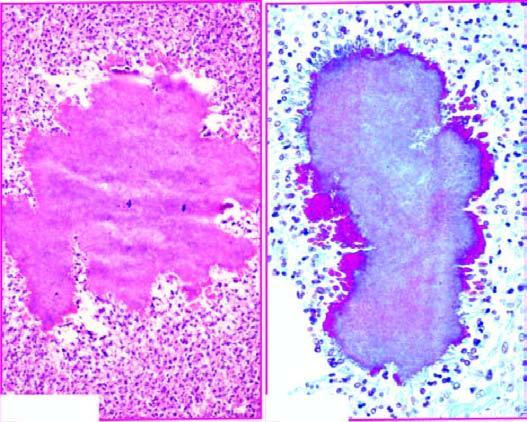does the margin of the colony show hyaline filaments highlighted by masson 's trichrome stain right photomicrograph?
Answer the question using a single word or phrase. Yes 